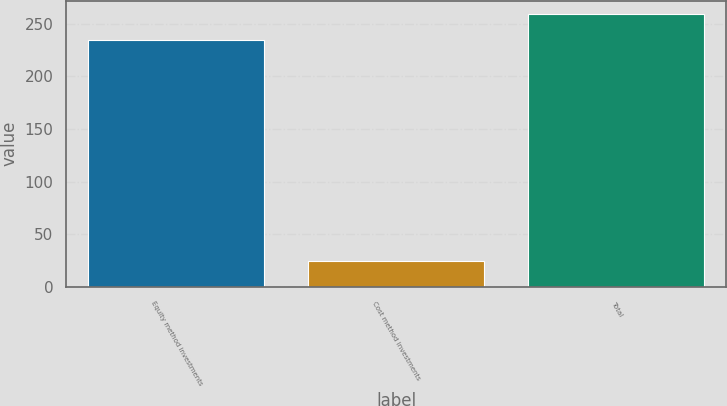Convert chart to OTSL. <chart><loc_0><loc_0><loc_500><loc_500><bar_chart><fcel>Equity method investments<fcel>Cost method investments<fcel>Total<nl><fcel>234.5<fcel>24.4<fcel>258.9<nl></chart> 